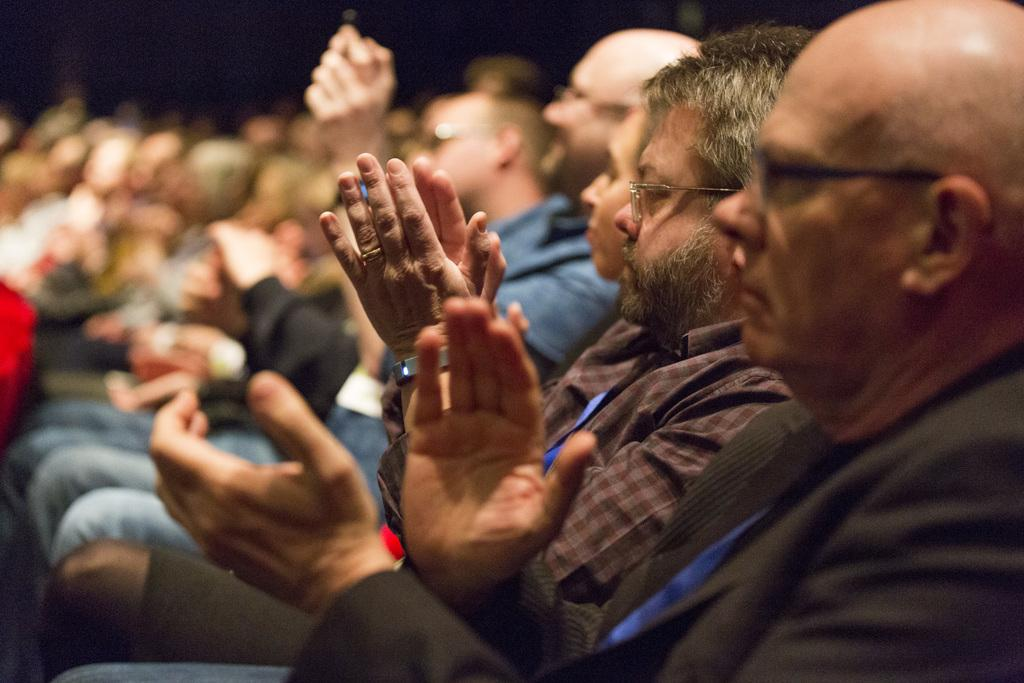What are the people in the image doing? The people in the image are sitting on chairs. Can you describe the background of the image? The background of the image is blurry. What is the income of the person sitting on the chair in the image? There is no information about the income of the person in the image. 